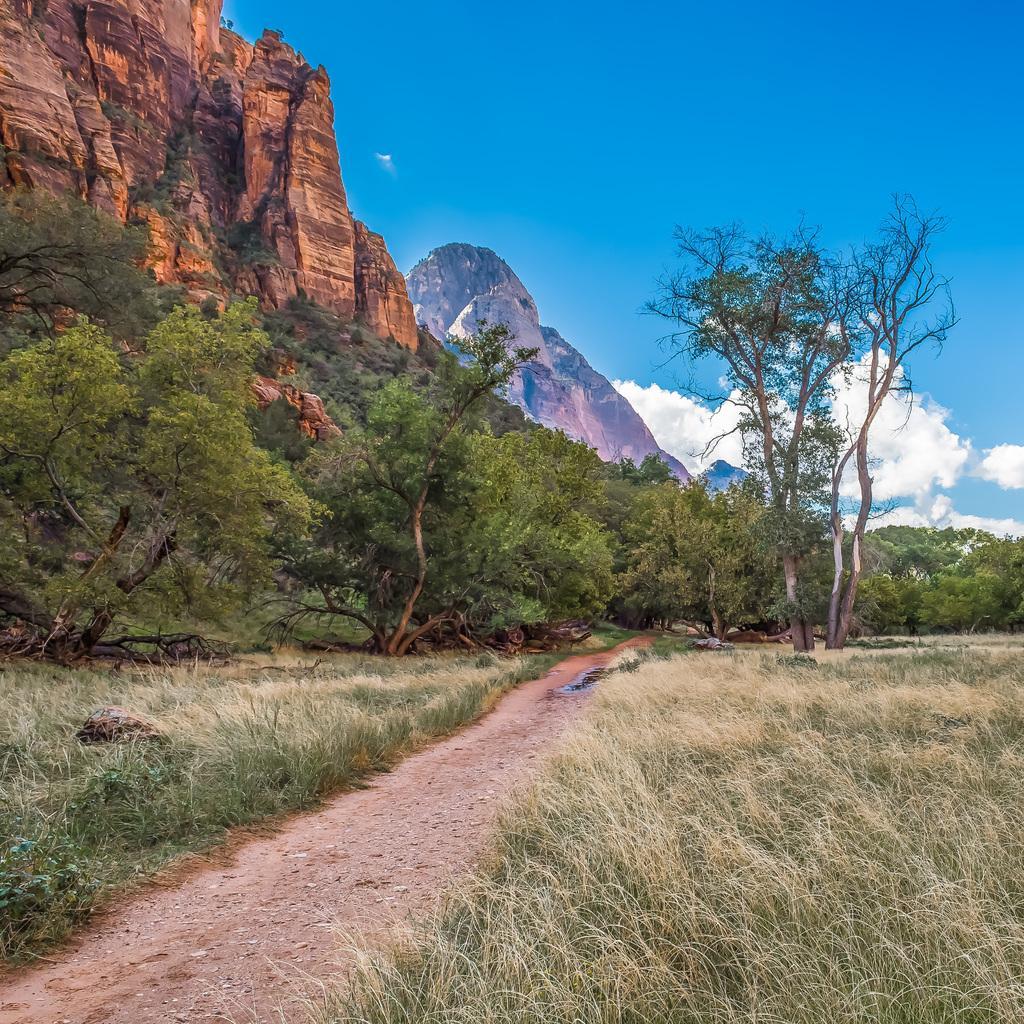Please provide a concise description of this image. In this image we can see grass, some trees, mountains and sky with the clouds. 